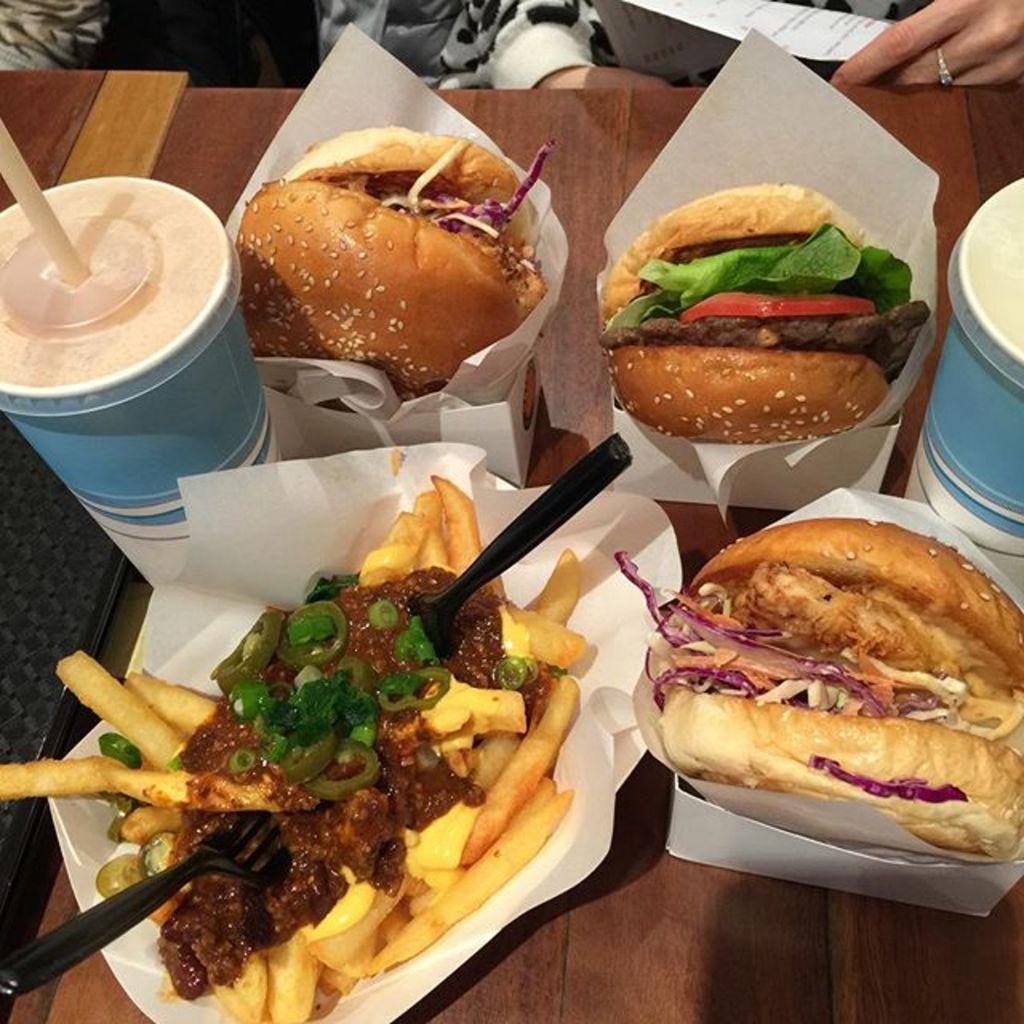Could you give a brief overview of what you see in this image? In this picture we can see food items with boxes, glasses, straw, fork, spoon and an object and these all are placed on a platform and in the background we can see people, paper. 